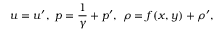Convert formula to latex. <formula><loc_0><loc_0><loc_500><loc_500>u = u ^ { \prime } , p = \frac { 1 } { \gamma } + p ^ { \prime } , \rho = f ( x , y ) + \rho ^ { \prime } ,</formula> 